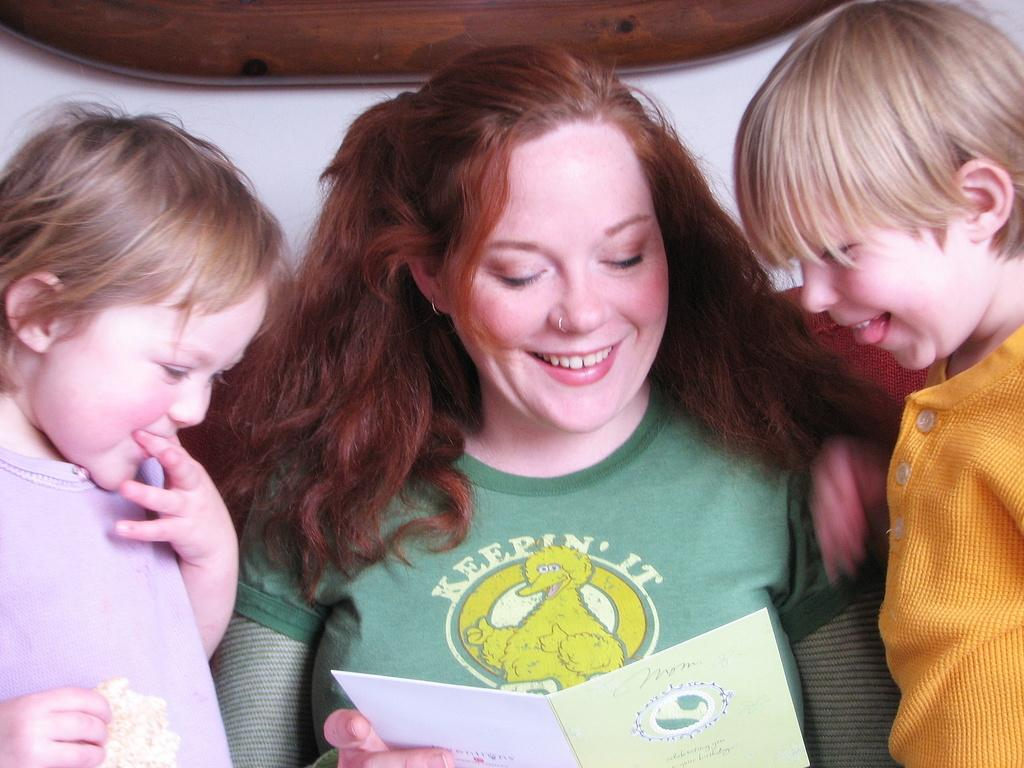How many kids are in the image? There are two kids in the image. What is the facial expression of the kids? The kids are smiling. Who else is present in the image besides the kids? There is a woman in the image. What is the facial expression of the woman? The woman is smiling. What is the woman holding in the image? The woman is holding a card. What can be seen in the background of the image? There is a wooden object in the background of the image. What is the woman's opinion on the beetle in the image? There is no beetle present in the image, so it is not possible to determine the woman's opinion on it. How is the hook used in the image? There is no hook present in the image, so it cannot be used for any purpose in the image. 